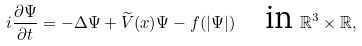<formula> <loc_0><loc_0><loc_500><loc_500>i \frac { \partial \Psi } { \partial t } = - \Delta \Psi + \widetilde { V } ( x ) \Psi - f ( | \Psi | ) \quad \text {in} \ \mathbb { R } ^ { 3 } \times \mathbb { R } ,</formula> 